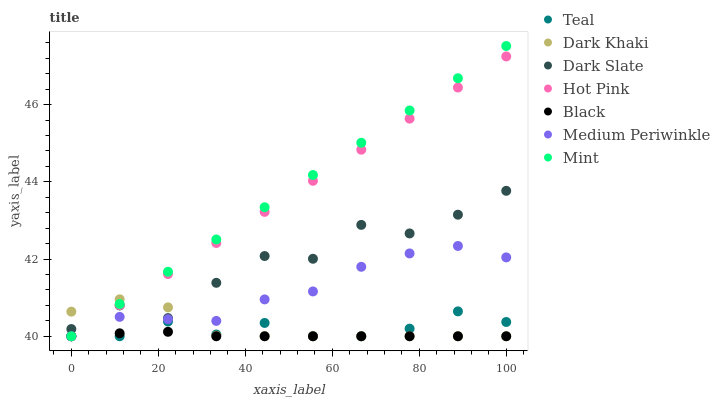Does Black have the minimum area under the curve?
Answer yes or no. Yes. Does Mint have the maximum area under the curve?
Answer yes or no. Yes. Does Medium Periwinkle have the minimum area under the curve?
Answer yes or no. No. Does Medium Periwinkle have the maximum area under the curve?
Answer yes or no. No. Is Hot Pink the smoothest?
Answer yes or no. Yes. Is Dark Slate the roughest?
Answer yes or no. Yes. Is Medium Periwinkle the smoothest?
Answer yes or no. No. Is Medium Periwinkle the roughest?
Answer yes or no. No. Does Hot Pink have the lowest value?
Answer yes or no. Yes. Does Dark Slate have the lowest value?
Answer yes or no. No. Does Mint have the highest value?
Answer yes or no. Yes. Does Medium Periwinkle have the highest value?
Answer yes or no. No. Is Medium Periwinkle less than Dark Slate?
Answer yes or no. Yes. Is Dark Slate greater than Medium Periwinkle?
Answer yes or no. Yes. Does Medium Periwinkle intersect Hot Pink?
Answer yes or no. Yes. Is Medium Periwinkle less than Hot Pink?
Answer yes or no. No. Is Medium Periwinkle greater than Hot Pink?
Answer yes or no. No. Does Medium Periwinkle intersect Dark Slate?
Answer yes or no. No. 